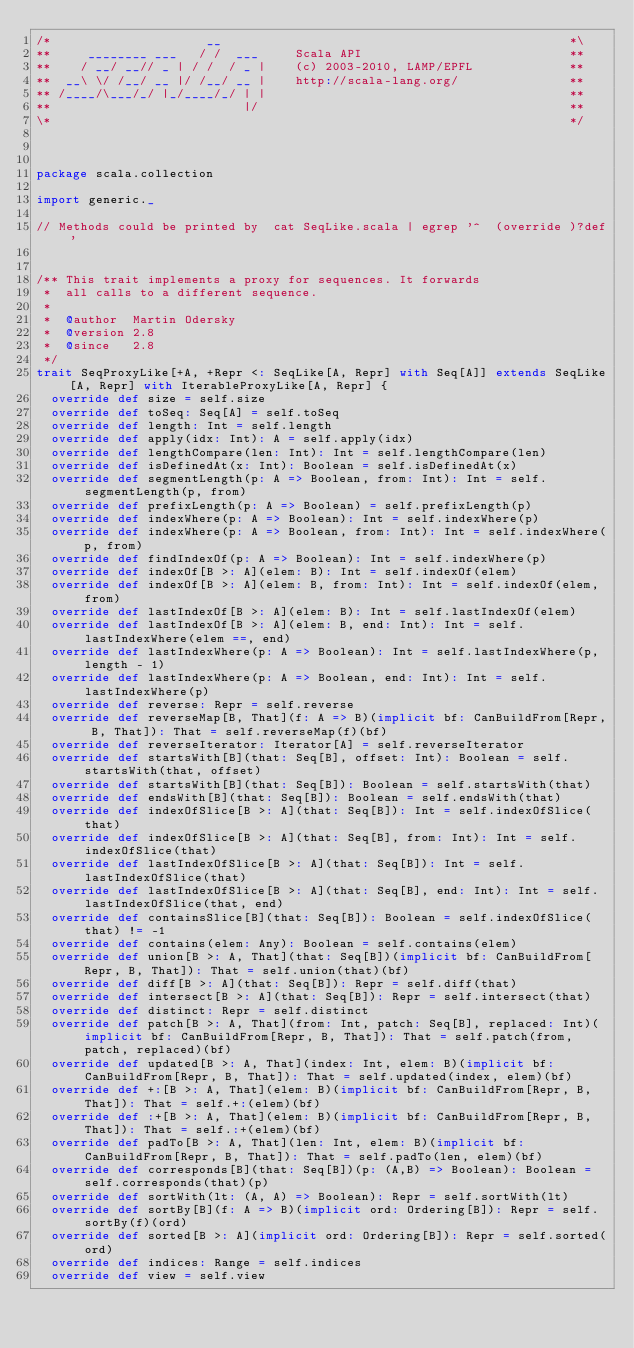Convert code to text. <code><loc_0><loc_0><loc_500><loc_500><_Scala_>/*                     __                                               *\
**     ________ ___   / /  ___     Scala API                            **
**    / __/ __// _ | / /  / _ |    (c) 2003-2010, LAMP/EPFL             **
**  __\ \/ /__/ __ |/ /__/ __ |    http://scala-lang.org/               **
** /____/\___/_/ |_/____/_/ | |                                         **
**                          |/                                          **
\*                                                                      */



package scala.collection

import generic._

// Methods could be printed by  cat SeqLike.scala | egrep '^  (override )?def'


/** This trait implements a proxy for sequences. It forwards
 *  all calls to a different sequence.
 *
 *  @author  Martin Odersky
 *  @version 2.8
 *  @since   2.8
 */
trait SeqProxyLike[+A, +Repr <: SeqLike[A, Repr] with Seq[A]] extends SeqLike[A, Repr] with IterableProxyLike[A, Repr] { 
  override def size = self.size
  override def toSeq: Seq[A] = self.toSeq
  override def length: Int = self.length
  override def apply(idx: Int): A = self.apply(idx)
  override def lengthCompare(len: Int): Int = self.lengthCompare(len)
  override def isDefinedAt(x: Int): Boolean = self.isDefinedAt(x)
  override def segmentLength(p: A => Boolean, from: Int): Int = self.segmentLength(p, from)
  override def prefixLength(p: A => Boolean) = self.prefixLength(p)
  override def indexWhere(p: A => Boolean): Int = self.indexWhere(p)
  override def indexWhere(p: A => Boolean, from: Int): Int = self.indexWhere(p, from)
  override def findIndexOf(p: A => Boolean): Int = self.indexWhere(p)
  override def indexOf[B >: A](elem: B): Int = self.indexOf(elem)
  override def indexOf[B >: A](elem: B, from: Int): Int = self.indexOf(elem, from)
  override def lastIndexOf[B >: A](elem: B): Int = self.lastIndexOf(elem)
  override def lastIndexOf[B >: A](elem: B, end: Int): Int = self.lastIndexWhere(elem ==, end)
  override def lastIndexWhere(p: A => Boolean): Int = self.lastIndexWhere(p, length - 1)
  override def lastIndexWhere(p: A => Boolean, end: Int): Int = self.lastIndexWhere(p)
  override def reverse: Repr = self.reverse
  override def reverseMap[B, That](f: A => B)(implicit bf: CanBuildFrom[Repr, B, That]): That = self.reverseMap(f)(bf)
  override def reverseIterator: Iterator[A] = self.reverseIterator
  override def startsWith[B](that: Seq[B], offset: Int): Boolean = self.startsWith(that, offset)
  override def startsWith[B](that: Seq[B]): Boolean = self.startsWith(that)
  override def endsWith[B](that: Seq[B]): Boolean = self.endsWith(that)
  override def indexOfSlice[B >: A](that: Seq[B]): Int = self.indexOfSlice(that)
  override def indexOfSlice[B >: A](that: Seq[B], from: Int): Int = self.indexOfSlice(that)
  override def lastIndexOfSlice[B >: A](that: Seq[B]): Int = self.lastIndexOfSlice(that)
  override def lastIndexOfSlice[B >: A](that: Seq[B], end: Int): Int = self.lastIndexOfSlice(that, end)
  override def containsSlice[B](that: Seq[B]): Boolean = self.indexOfSlice(that) != -1
  override def contains(elem: Any): Boolean = self.contains(elem)
  override def union[B >: A, That](that: Seq[B])(implicit bf: CanBuildFrom[Repr, B, That]): That = self.union(that)(bf)
  override def diff[B >: A](that: Seq[B]): Repr = self.diff(that)
  override def intersect[B >: A](that: Seq[B]): Repr = self.intersect(that)
  override def distinct: Repr = self.distinct
  override def patch[B >: A, That](from: Int, patch: Seq[B], replaced: Int)(implicit bf: CanBuildFrom[Repr, B, That]): That = self.patch(from, patch, replaced)(bf)
  override def updated[B >: A, That](index: Int, elem: B)(implicit bf: CanBuildFrom[Repr, B, That]): That = self.updated(index, elem)(bf)
  override def +:[B >: A, That](elem: B)(implicit bf: CanBuildFrom[Repr, B, That]): That = self.+:(elem)(bf)
  override def :+[B >: A, That](elem: B)(implicit bf: CanBuildFrom[Repr, B, That]): That = self.:+(elem)(bf)
  override def padTo[B >: A, That](len: Int, elem: B)(implicit bf: CanBuildFrom[Repr, B, That]): That = self.padTo(len, elem)(bf)
  override def corresponds[B](that: Seq[B])(p: (A,B) => Boolean): Boolean = self.corresponds(that)(p)
  override def sortWith(lt: (A, A) => Boolean): Repr = self.sortWith(lt)
  override def sortBy[B](f: A => B)(implicit ord: Ordering[B]): Repr = self.sortBy(f)(ord)
  override def sorted[B >: A](implicit ord: Ordering[B]): Repr = self.sorted(ord)
  override def indices: Range = self.indices
  override def view = self.view</code> 